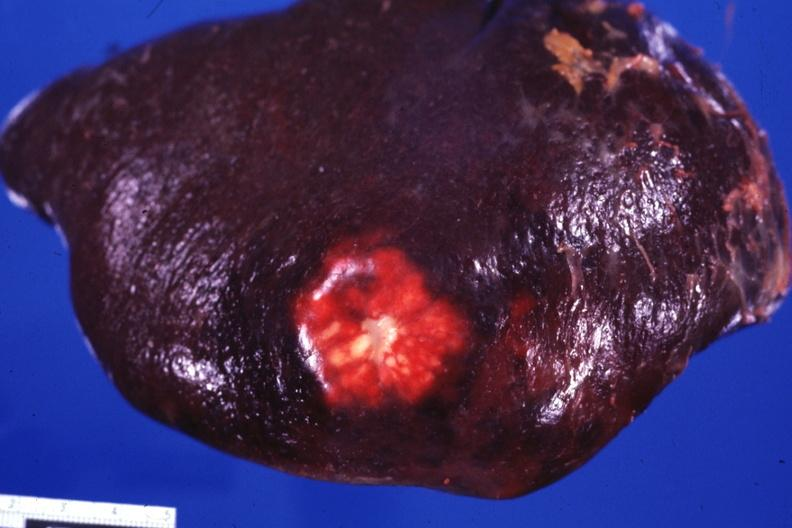s choanal atresia present?
Answer the question using a single word or phrase. No 